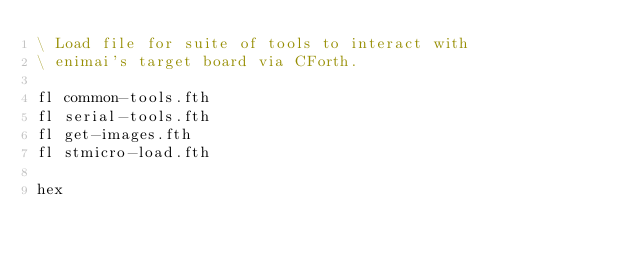<code> <loc_0><loc_0><loc_500><loc_500><_Forth_>\ Load file for suite of tools to interact with
\ enimai's target board via CForth.

fl common-tools.fth
fl serial-tools.fth
fl get-images.fth
fl stmicro-load.fth

hex
</code> 